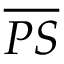<formula> <loc_0><loc_0><loc_500><loc_500>\overline { P S }</formula> 